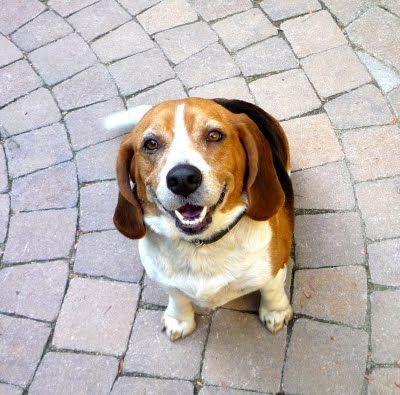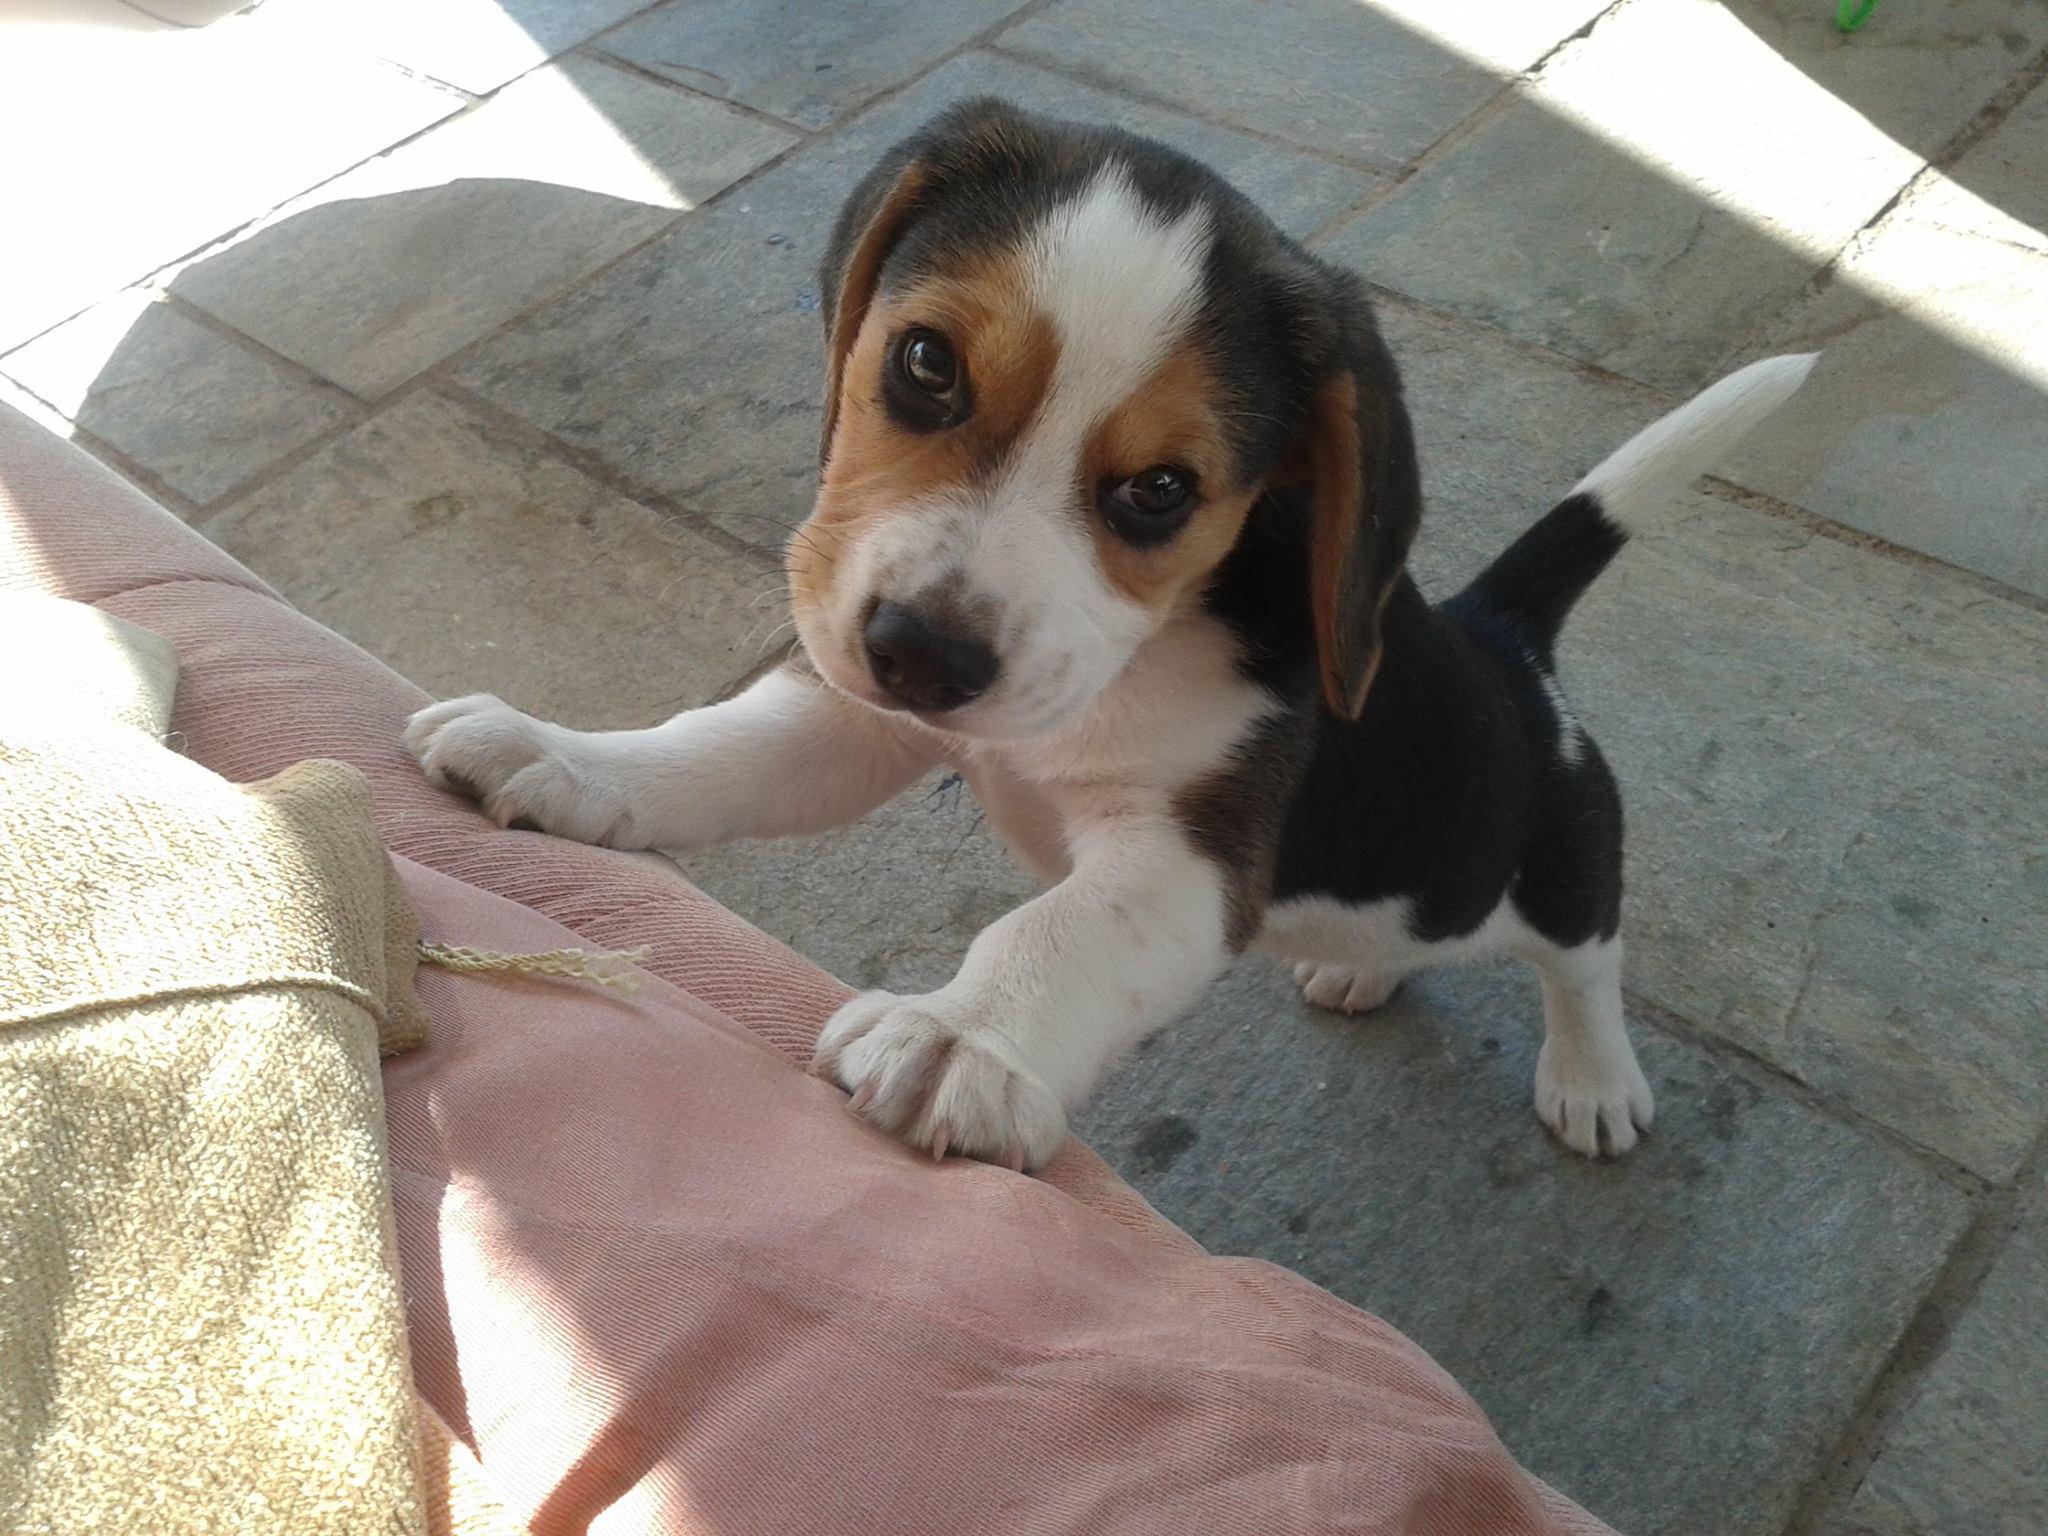The first image is the image on the left, the second image is the image on the right. Analyze the images presented: Is the assertion "All dogs are looking up at the camera, at least one dog has an open mouth, and no image contains more than two dogs." valid? Answer yes or no. Yes. The first image is the image on the left, the second image is the image on the right. Examine the images to the left and right. Is the description "There are at least two dogs in the left image." accurate? Answer yes or no. No. 